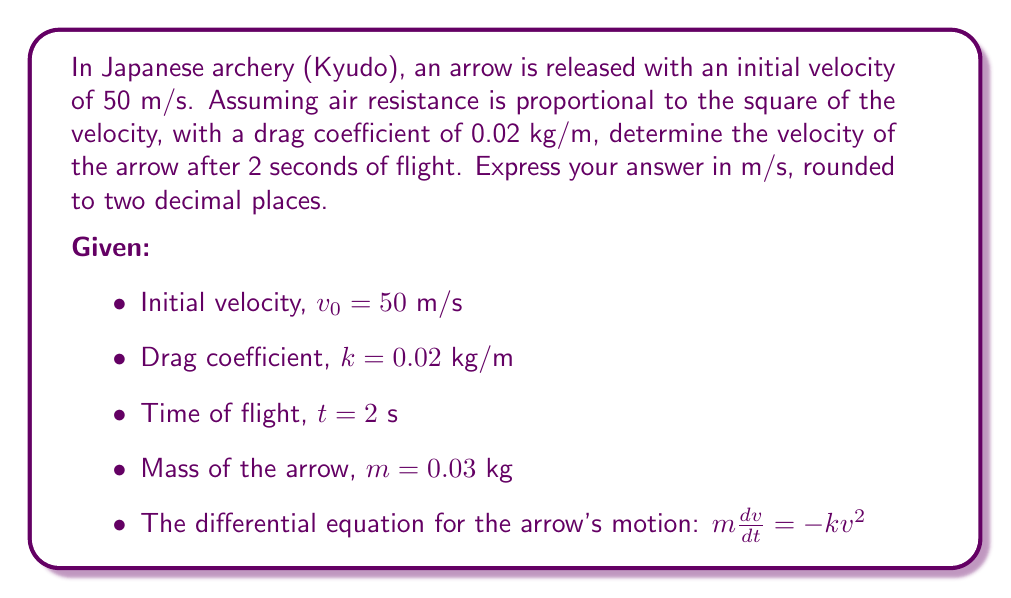Solve this math problem. To solve this problem, we need to use the given differential equation and initial conditions. Let's approach this step-by-step:

1) The differential equation describing the arrow's motion is:

   $$m\frac{dv}{dt} = -kv^2$$

2) Rearranging the equation:

   $$\frac{dv}{v^2} = -\frac{k}{m}dt$$

3) Integrating both sides:

   $$\int_{v_0}^v \frac{dv}{v^2} = -\frac{k}{m}\int_0^t dt$$

4) Solving the integrals:

   $$\left[-\frac{1}{v}\right]_{v_0}^v = -\frac{k}{m}[t]_0^t$$

5) Evaluating the definite integrals:

   $$-\frac{1}{v} + \frac{1}{v_0} = -\frac{kt}{m}$$

6) Solving for v:

   $$\frac{1}{v} = \frac{1}{v_0} + \frac{kt}{m}$$
   
   $$v = \frac{1}{\frac{1}{v_0} + \frac{kt}{m}}$$

7) Substituting the given values:

   $$v = \frac{1}{\frac{1}{50} + \frac{0.02 \cdot 2}{0.03}}$$

8) Calculating the result:

   $$v = \frac{1}{0.02 + 1.3333} = \frac{1}{1.3533} \approx 0.7389 \text{ m/s}$$

9) Rounding to two decimal places:

   $$v \approx 0.74 \text{ m/s}$$
Answer: The velocity of the arrow after 2 seconds of flight is approximately 0.74 m/s. 